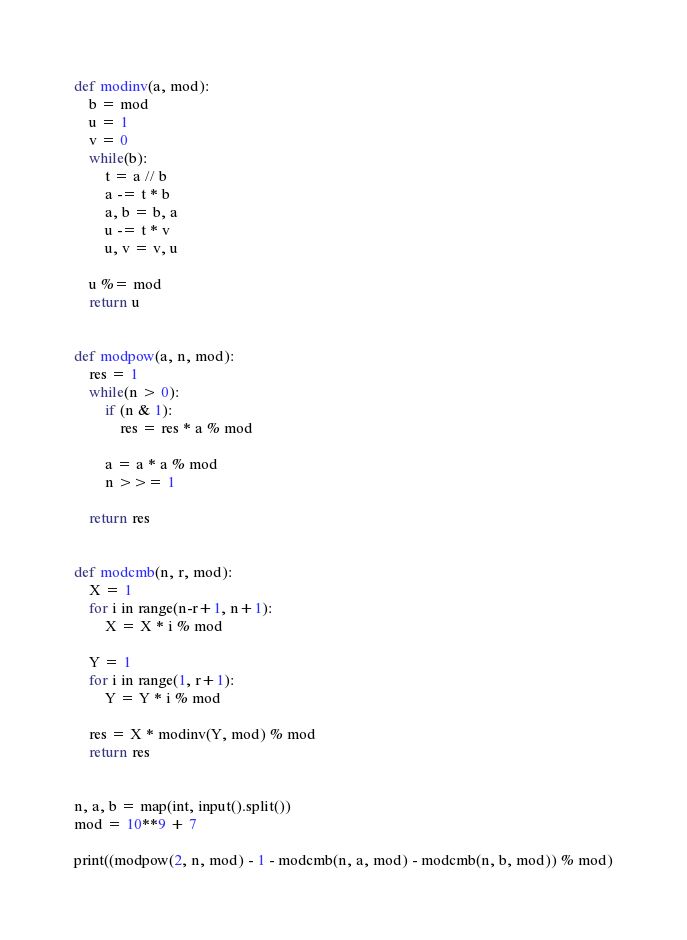<code> <loc_0><loc_0><loc_500><loc_500><_Python_>def modinv(a, mod):
    b = mod
    u = 1
    v = 0
    while(b):
        t = a // b
        a -= t * b
        a, b = b, a
        u -= t * v
        u, v = v, u

    u %= mod
    return u


def modpow(a, n, mod):
    res = 1
    while(n > 0):
        if (n & 1):
            res = res * a % mod

        a = a * a % mod
        n >>= 1
    
    return res


def modcmb(n, r, mod):
    X = 1
    for i in range(n-r+1, n+1):
        X = X * i % mod

    Y = 1
    for i in range(1, r+1):
        Y = Y * i % mod
        
    res = X * modinv(Y, mod) % mod
    return res


n, a, b = map(int, input().split())
mod = 10**9 + 7

print((modpow(2, n, mod) - 1 - modcmb(n, a, mod) - modcmb(n, b, mod)) % mod)</code> 